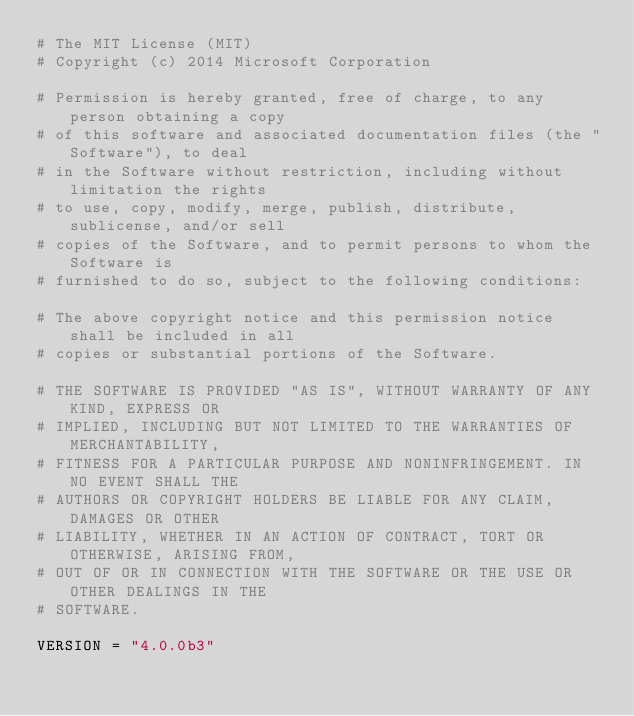Convert code to text. <code><loc_0><loc_0><loc_500><loc_500><_Python_># The MIT License (MIT)
# Copyright (c) 2014 Microsoft Corporation

# Permission is hereby granted, free of charge, to any person obtaining a copy
# of this software and associated documentation files (the "Software"), to deal
# in the Software without restriction, including without limitation the rights
# to use, copy, modify, merge, publish, distribute, sublicense, and/or sell
# copies of the Software, and to permit persons to whom the Software is
# furnished to do so, subject to the following conditions:

# The above copyright notice and this permission notice shall be included in all
# copies or substantial portions of the Software.

# THE SOFTWARE IS PROVIDED "AS IS", WITHOUT WARRANTY OF ANY KIND, EXPRESS OR
# IMPLIED, INCLUDING BUT NOT LIMITED TO THE WARRANTIES OF MERCHANTABILITY,
# FITNESS FOR A PARTICULAR PURPOSE AND NONINFRINGEMENT. IN NO EVENT SHALL THE
# AUTHORS OR COPYRIGHT HOLDERS BE LIABLE FOR ANY CLAIM, DAMAGES OR OTHER
# LIABILITY, WHETHER IN AN ACTION OF CONTRACT, TORT OR OTHERWISE, ARISING FROM,
# OUT OF OR IN CONNECTION WITH THE SOFTWARE OR THE USE OR OTHER DEALINGS IN THE
# SOFTWARE.

VERSION = "4.0.0b3"
</code> 